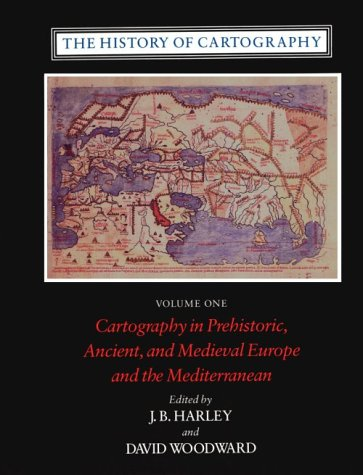Is this book related to Computers & Technology? No, although modern cartography uses technology, this particular volume focuses primarily on historical methods which predate contemporary technological applications. 